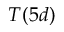Convert formula to latex. <formula><loc_0><loc_0><loc_500><loc_500>T ( 5 d )</formula> 